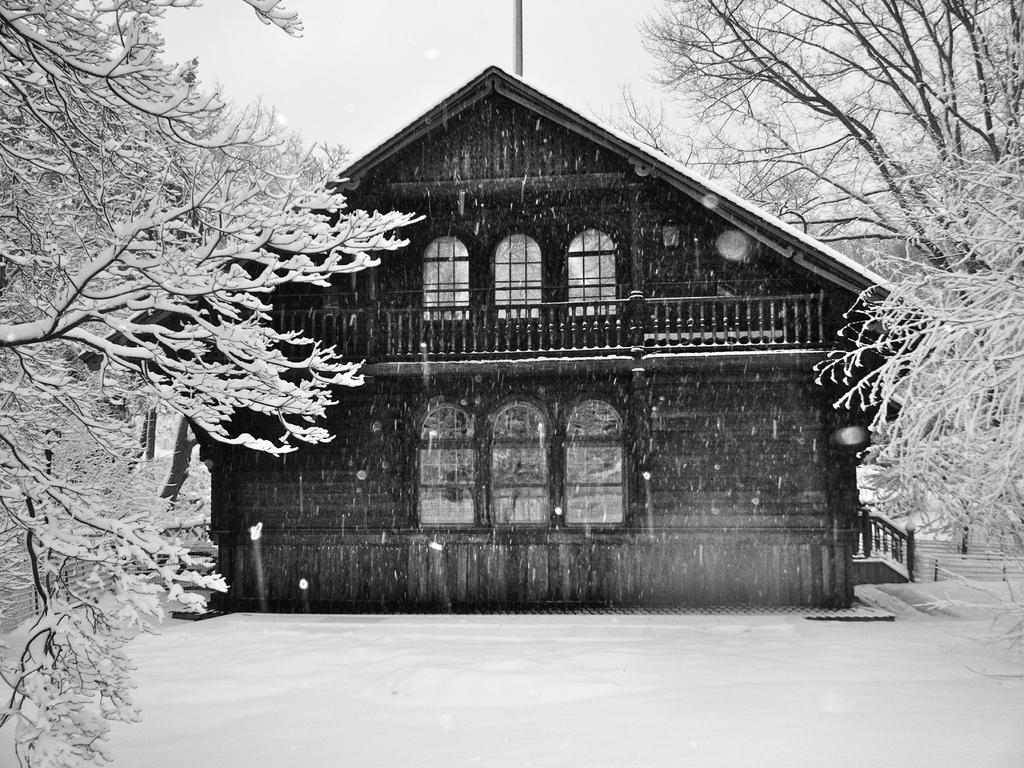What is the color scheme of the image? The image is black and white. What structure can be seen in the image? There is a house in the image. What feature of the house is mentioned in the facts? The house has glass windows. What is located near the house in the image? There are trees beside the house. What can be observed about the land in the image? The land is covered with snow. Can you see a thread being used for sewing in the image? There is no thread or sewing activity present in the image. 